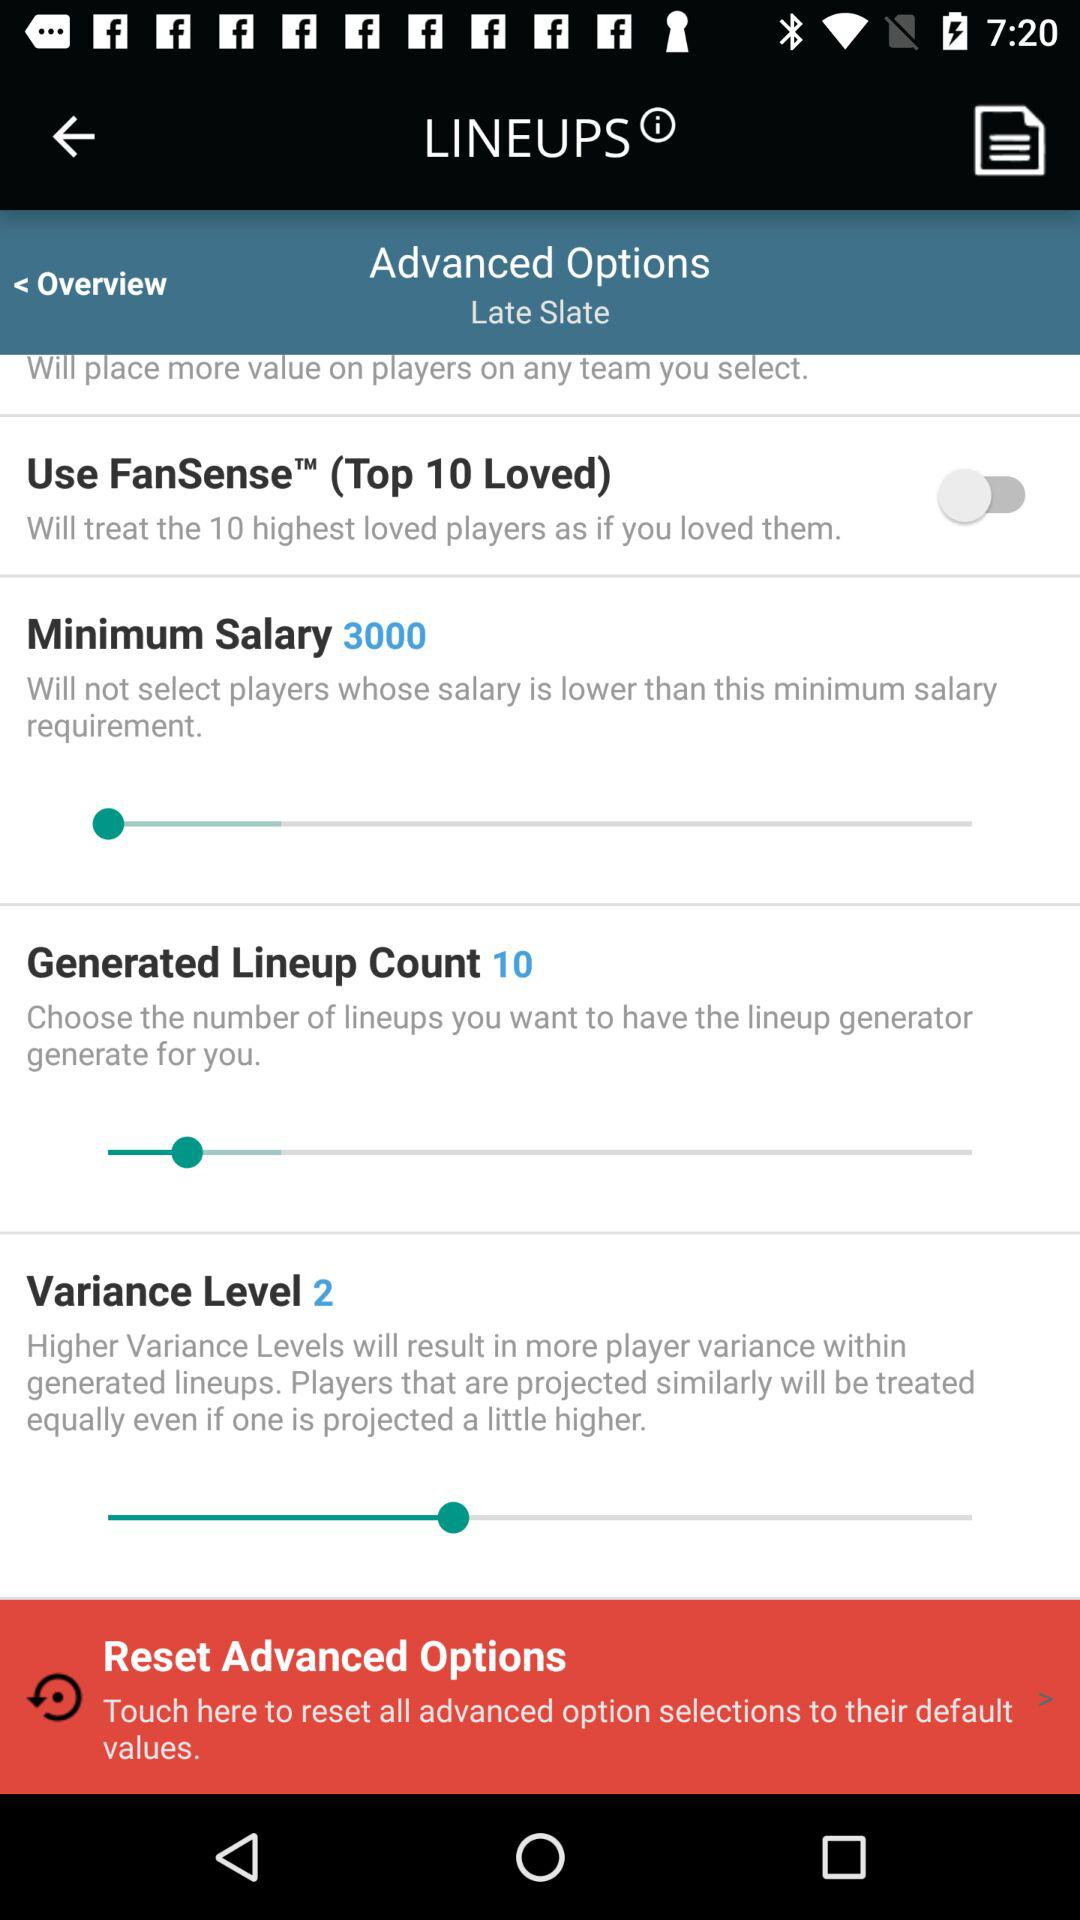What is the status of "Use FanSense"? The status is "off". 